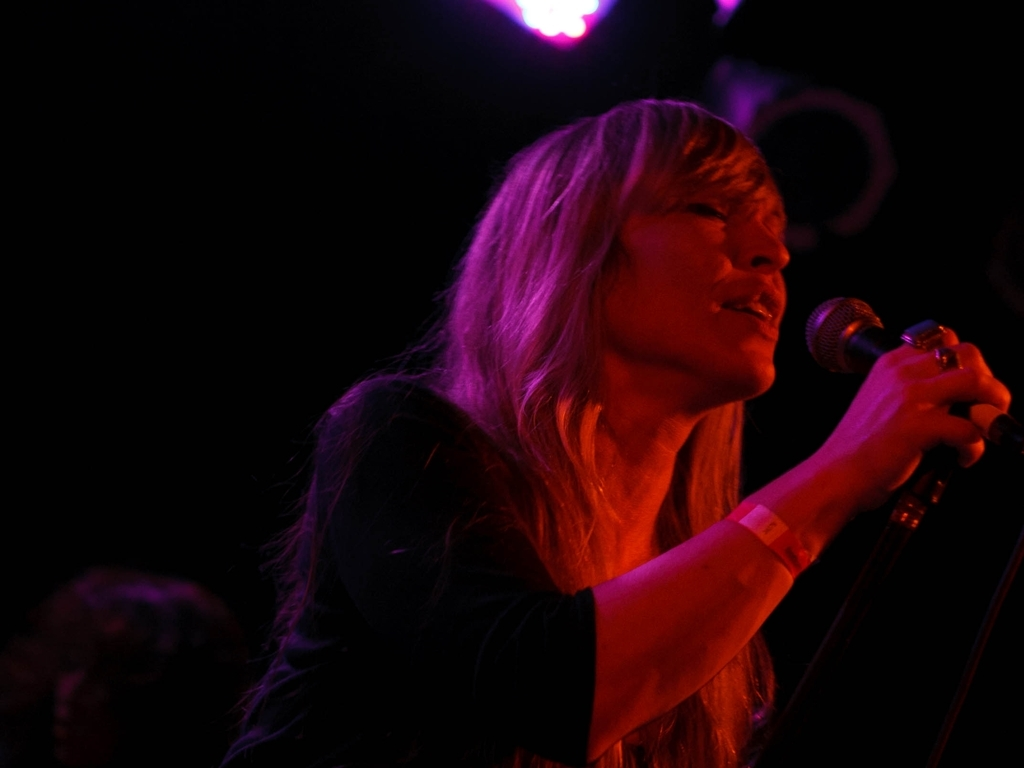What emotions does the performer seem to be expressing? The performer appears to be deeply immersed in the musical experience, conveying a sense of passion and emotional intensity. The eyes are closed, which often suggests a feeling of introspection or being lost in the moment. 